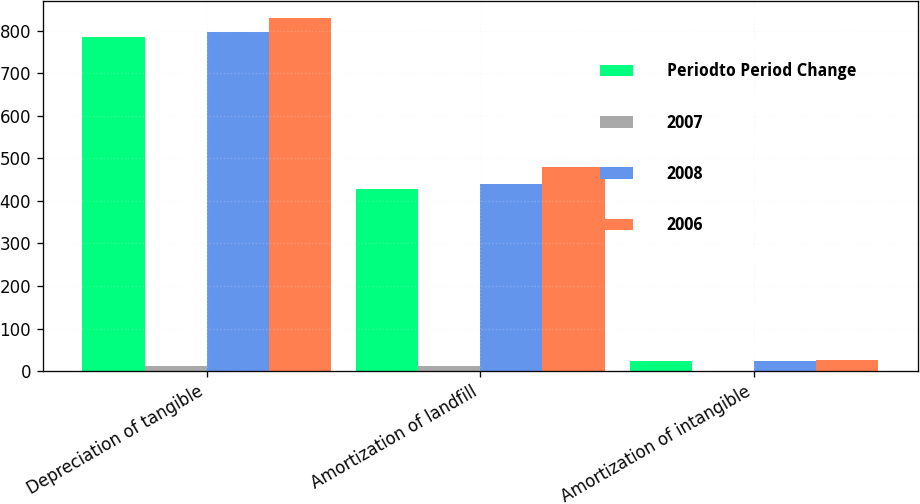Convert chart to OTSL. <chart><loc_0><loc_0><loc_500><loc_500><stacked_bar_chart><ecel><fcel>Depreciation of tangible<fcel>Amortization of landfill<fcel>Amortization of intangible<nl><fcel>Periodto Period Change<fcel>785<fcel>429<fcel>24<nl><fcel>2007<fcel>11<fcel>11<fcel>1<nl><fcel>2008<fcel>796<fcel>440<fcel>23<nl><fcel>2006<fcel>829<fcel>479<fcel>26<nl></chart> 